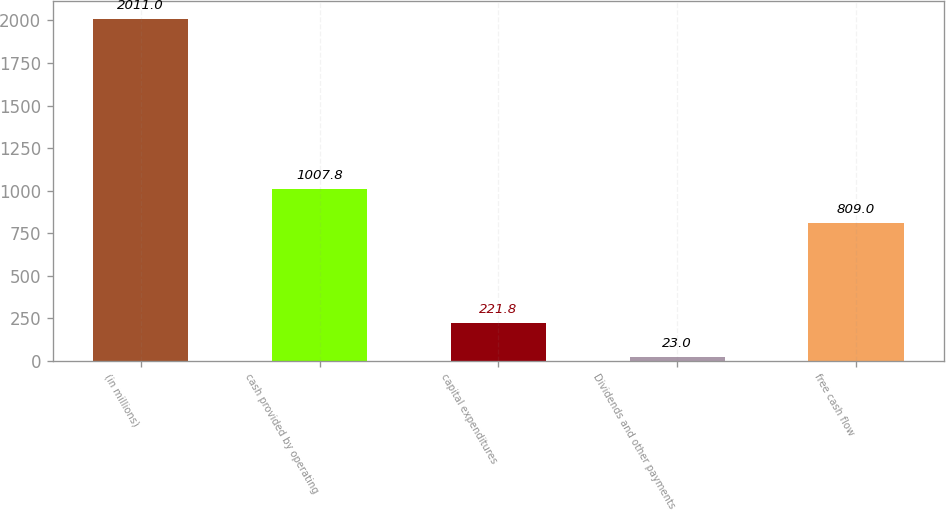Convert chart. <chart><loc_0><loc_0><loc_500><loc_500><bar_chart><fcel>(in millions)<fcel>cash provided by operating<fcel>capital expenditures<fcel>Dividends and other payments<fcel>free cash flow<nl><fcel>2011<fcel>1007.8<fcel>221.8<fcel>23<fcel>809<nl></chart> 